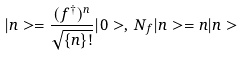<formula> <loc_0><loc_0><loc_500><loc_500>| n > = \frac { ( f ^ { \dagger } ) ^ { n } } { \sqrt { \{ n \} ! } } | 0 > , \, N _ { f } | n > = n | n ></formula> 